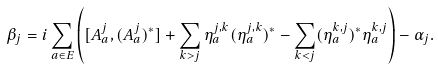Convert formula to latex. <formula><loc_0><loc_0><loc_500><loc_500>\beta _ { j } = i \sum _ { a \in E } \left ( [ A _ { a } ^ { j } , ( A _ { a } ^ { j } ) ^ { * } ] + \sum _ { k > j } \eta _ { a } ^ { j , k } ( \eta _ { a } ^ { j , k } ) ^ { * } - \sum _ { k < j } ( \eta _ { a } ^ { k , j } ) ^ { * } \eta _ { a } ^ { k , j } \right ) - \alpha _ { j } .</formula> 